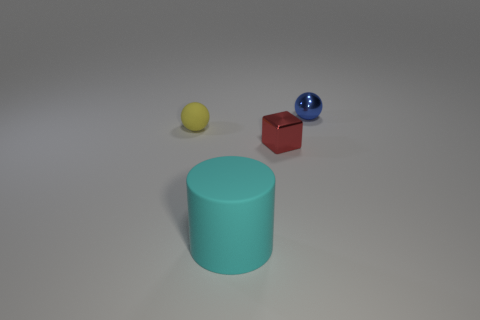Add 2 small spheres. How many objects exist? 6 Subtract 1 cubes. How many cubes are left? 0 Subtract all brown cubes. Subtract all gray cylinders. How many cubes are left? 1 Subtract all red cubes. How many yellow spheres are left? 1 Subtract all big green metal blocks. Subtract all small matte balls. How many objects are left? 3 Add 1 small blue metallic objects. How many small blue metallic objects are left? 2 Add 3 big red cylinders. How many big red cylinders exist? 3 Subtract 0 gray cylinders. How many objects are left? 4 